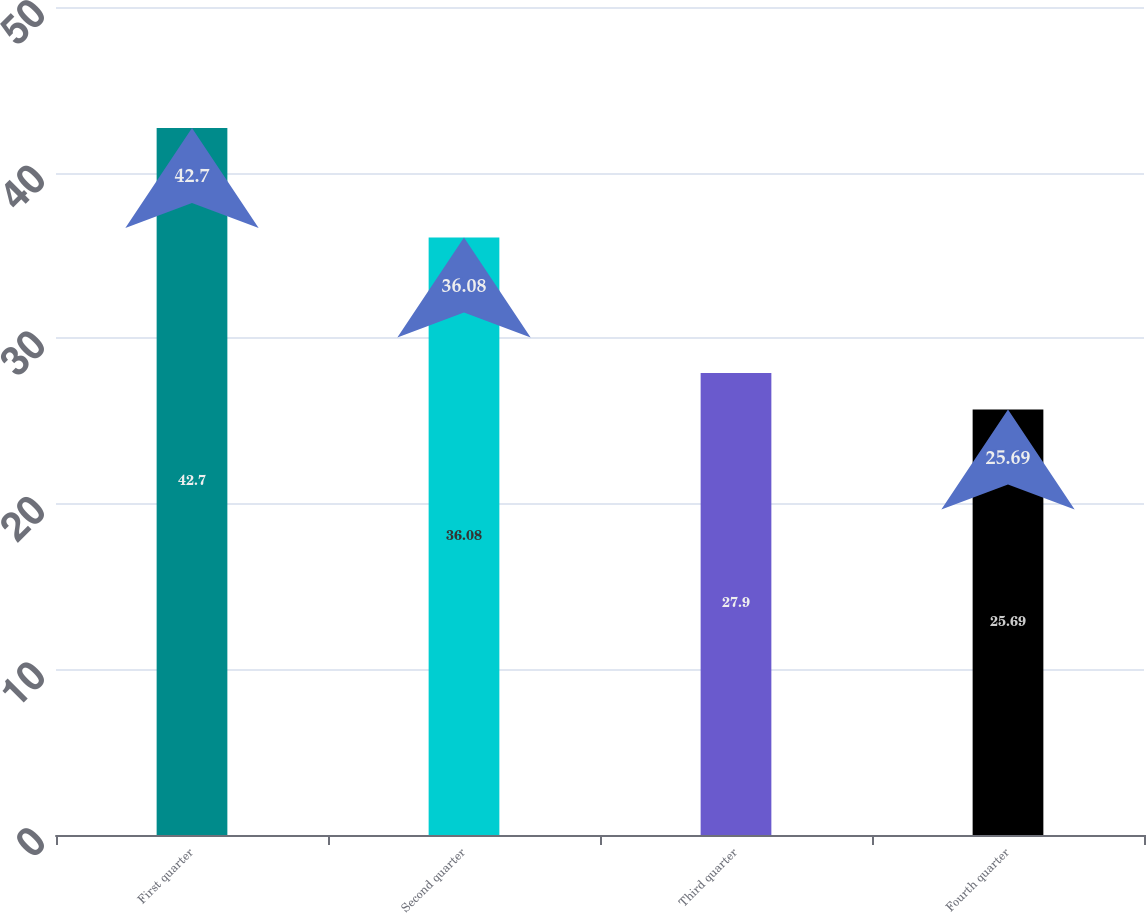Convert chart. <chart><loc_0><loc_0><loc_500><loc_500><bar_chart><fcel>First quarter<fcel>Second quarter<fcel>Third quarter<fcel>Fourth quarter<nl><fcel>42.7<fcel>36.08<fcel>27.9<fcel>25.69<nl></chart> 